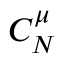<formula> <loc_0><loc_0><loc_500><loc_500>C _ { N } ^ { \mu }</formula> 